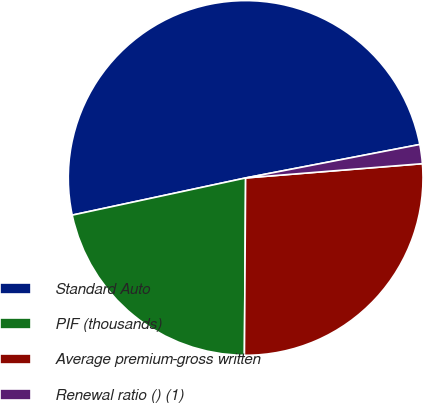<chart> <loc_0><loc_0><loc_500><loc_500><pie_chart><fcel>Standard Auto<fcel>PIF (thousands)<fcel>Average premium-gross written<fcel>Renewal ratio () (1)<nl><fcel>50.34%<fcel>21.53%<fcel>26.39%<fcel>1.74%<nl></chart> 